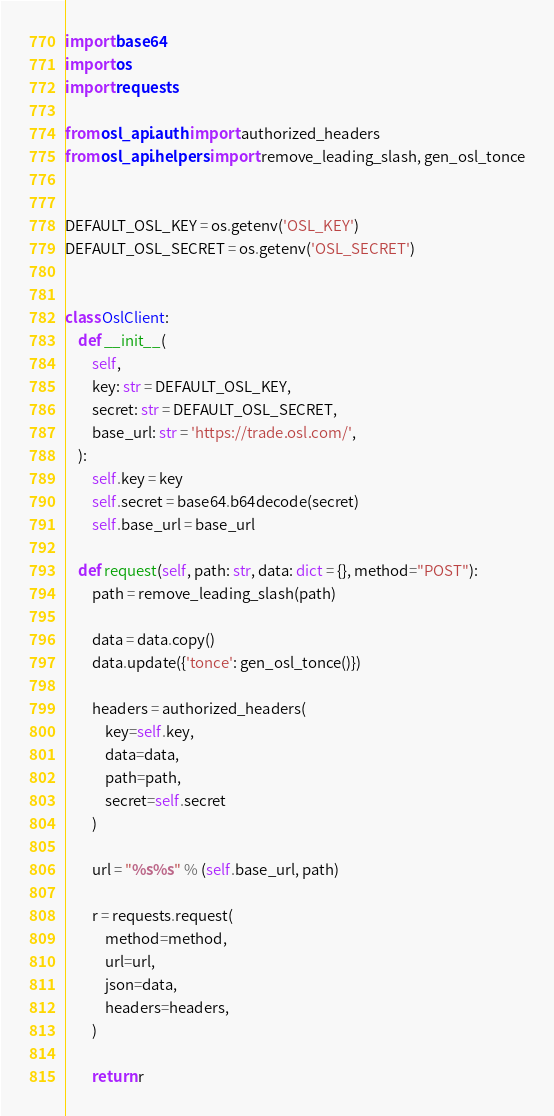<code> <loc_0><loc_0><loc_500><loc_500><_Python_>import base64
import os
import requests

from osl_api.auth import authorized_headers
from osl_api.helpers import remove_leading_slash, gen_osl_tonce


DEFAULT_OSL_KEY = os.getenv('OSL_KEY')
DEFAULT_OSL_SECRET = os.getenv('OSL_SECRET')


class OslClient:
    def __init__(
        self,
        key: str = DEFAULT_OSL_KEY,
        secret: str = DEFAULT_OSL_SECRET,
        base_url: str = 'https://trade.osl.com/',
    ):
        self.key = key
        self.secret = base64.b64decode(secret)
        self.base_url = base_url

    def request(self, path: str, data: dict = {}, method="POST"):
        path = remove_leading_slash(path)

        data = data.copy()
        data.update({'tonce': gen_osl_tonce()})

        headers = authorized_headers(
            key=self.key,
            data=data,
            path=path,
            secret=self.secret
        )

        url = "%s%s" % (self.base_url, path)

        r = requests.request(
            method=method,
            url=url,
            json=data,
            headers=headers,
        )

        return r
</code> 